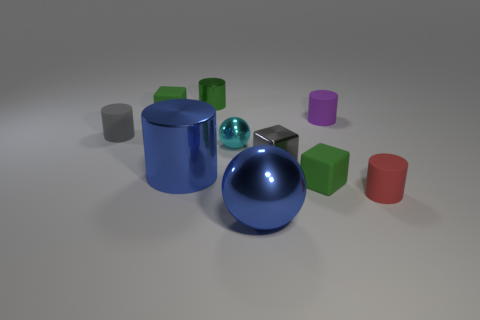Subtract all gray cubes. How many cubes are left? 2 Subtract all tiny matte cylinders. How many cylinders are left? 2 Subtract 1 blue balls. How many objects are left? 9 Subtract all balls. How many objects are left? 8 Subtract 4 cylinders. How many cylinders are left? 1 Subtract all yellow cylinders. Subtract all red spheres. How many cylinders are left? 5 Subtract all blue spheres. How many gray blocks are left? 1 Subtract all big green metallic balls. Subtract all gray objects. How many objects are left? 8 Add 6 gray metallic things. How many gray metallic things are left? 7 Add 10 tiny red metal spheres. How many tiny red metal spheres exist? 10 